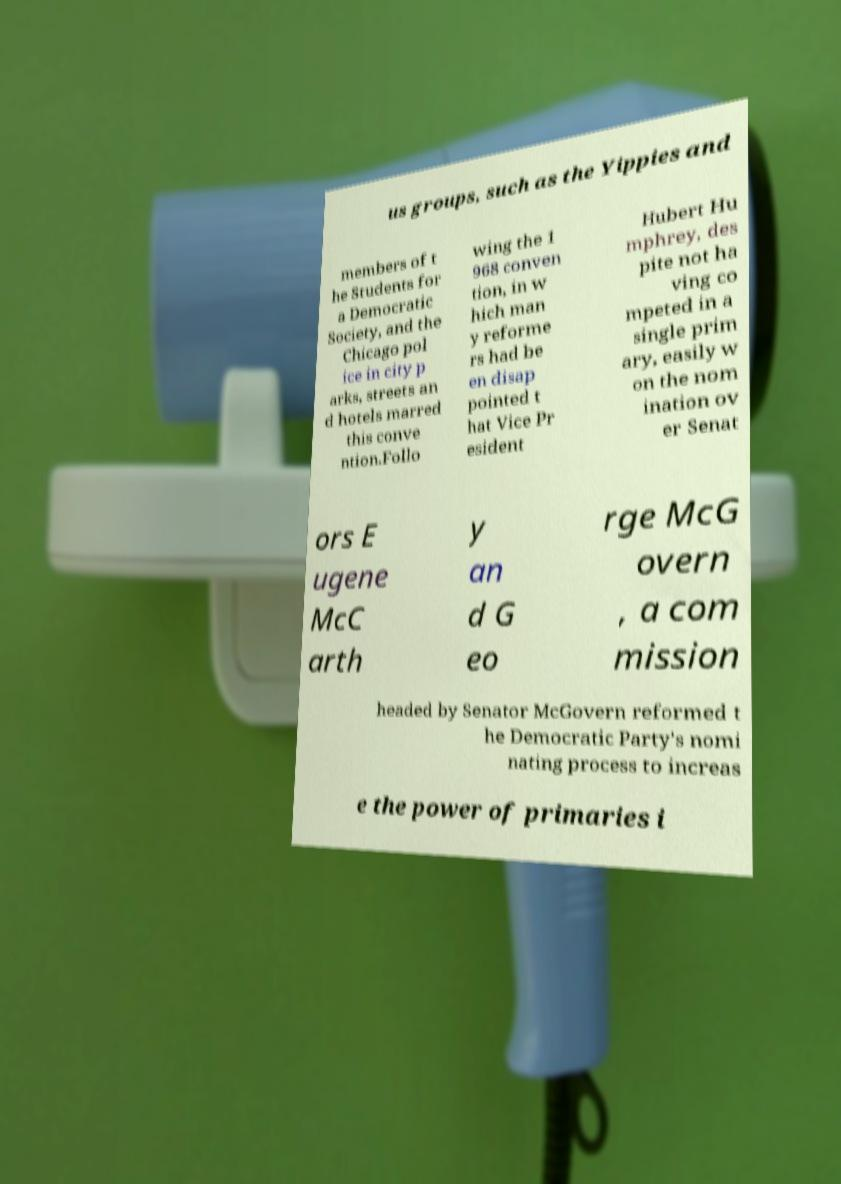Could you extract and type out the text from this image? us groups, such as the Yippies and members of t he Students for a Democratic Society, and the Chicago pol ice in city p arks, streets an d hotels marred this conve ntion.Follo wing the 1 968 conven tion, in w hich man y reforme rs had be en disap pointed t hat Vice Pr esident Hubert Hu mphrey, des pite not ha ving co mpeted in a single prim ary, easily w on the nom ination ov er Senat ors E ugene McC arth y an d G eo rge McG overn , a com mission headed by Senator McGovern reformed t he Democratic Party's nomi nating process to increas e the power of primaries i 